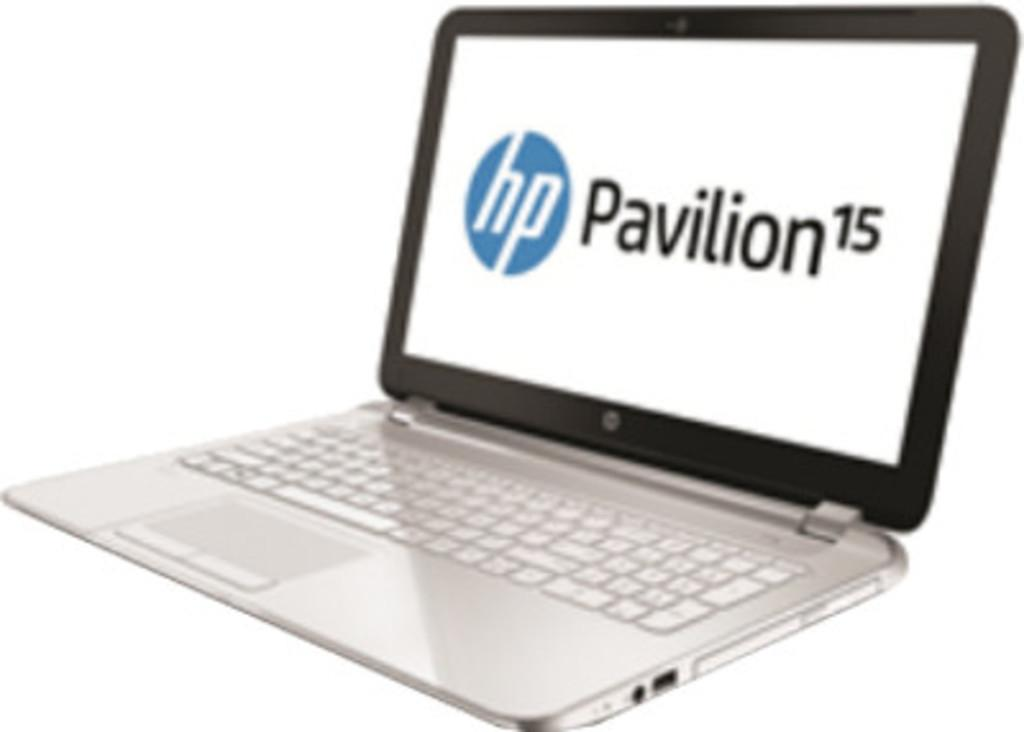<image>
Present a compact description of the photo's key features. A laptop with a screen that says hp Pavilion 15. 